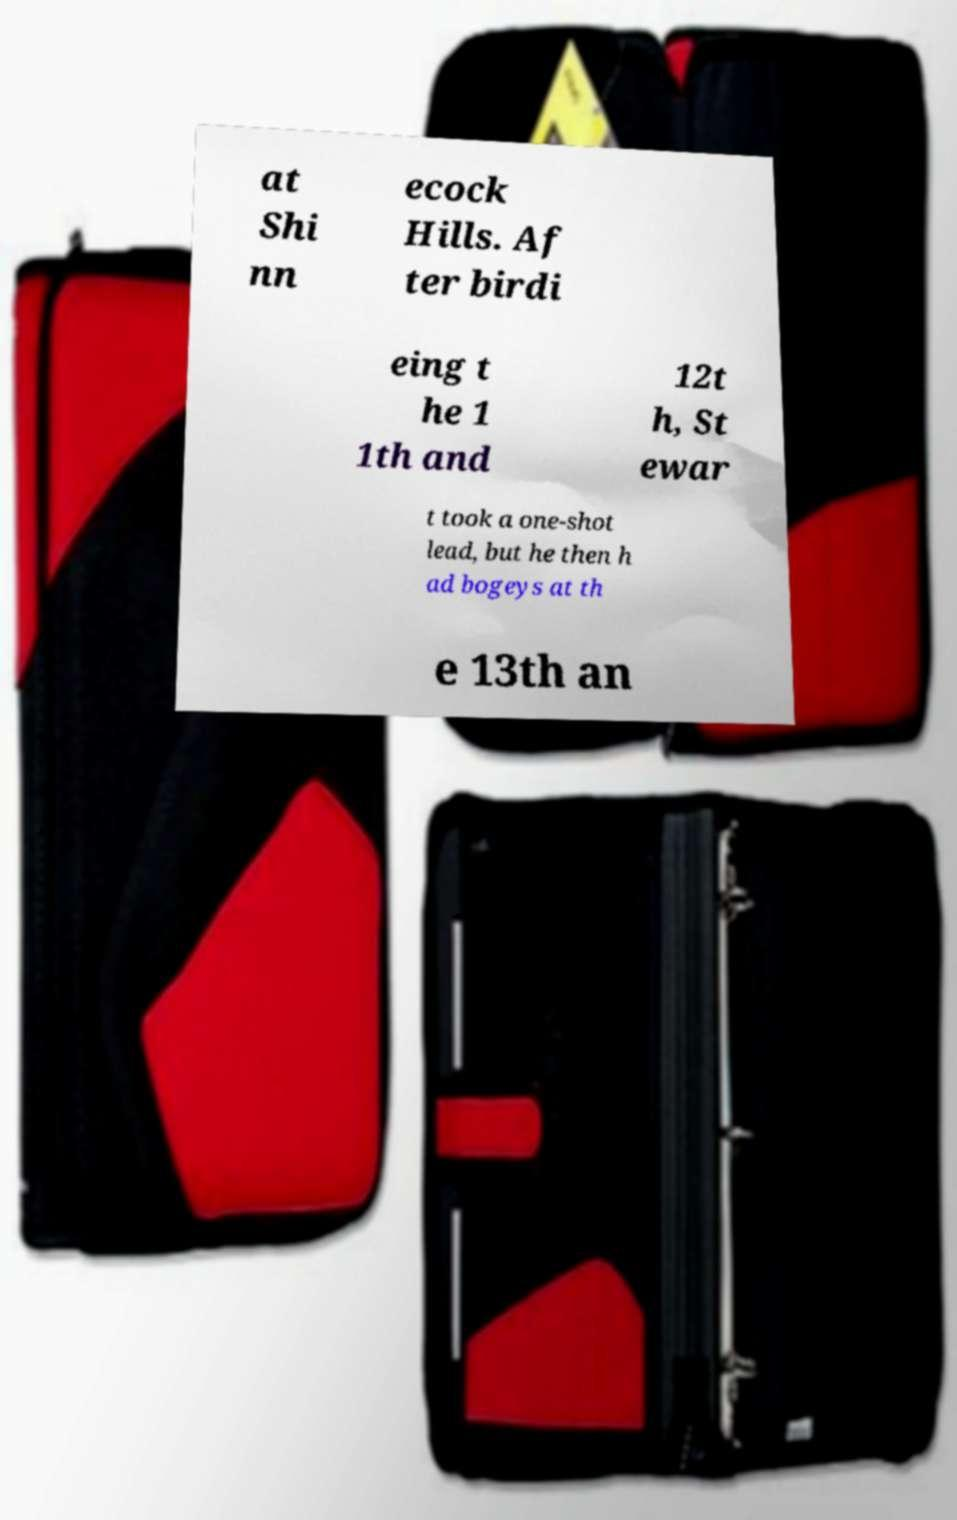Please identify and transcribe the text found in this image. at Shi nn ecock Hills. Af ter birdi eing t he 1 1th and 12t h, St ewar t took a one-shot lead, but he then h ad bogeys at th e 13th an 